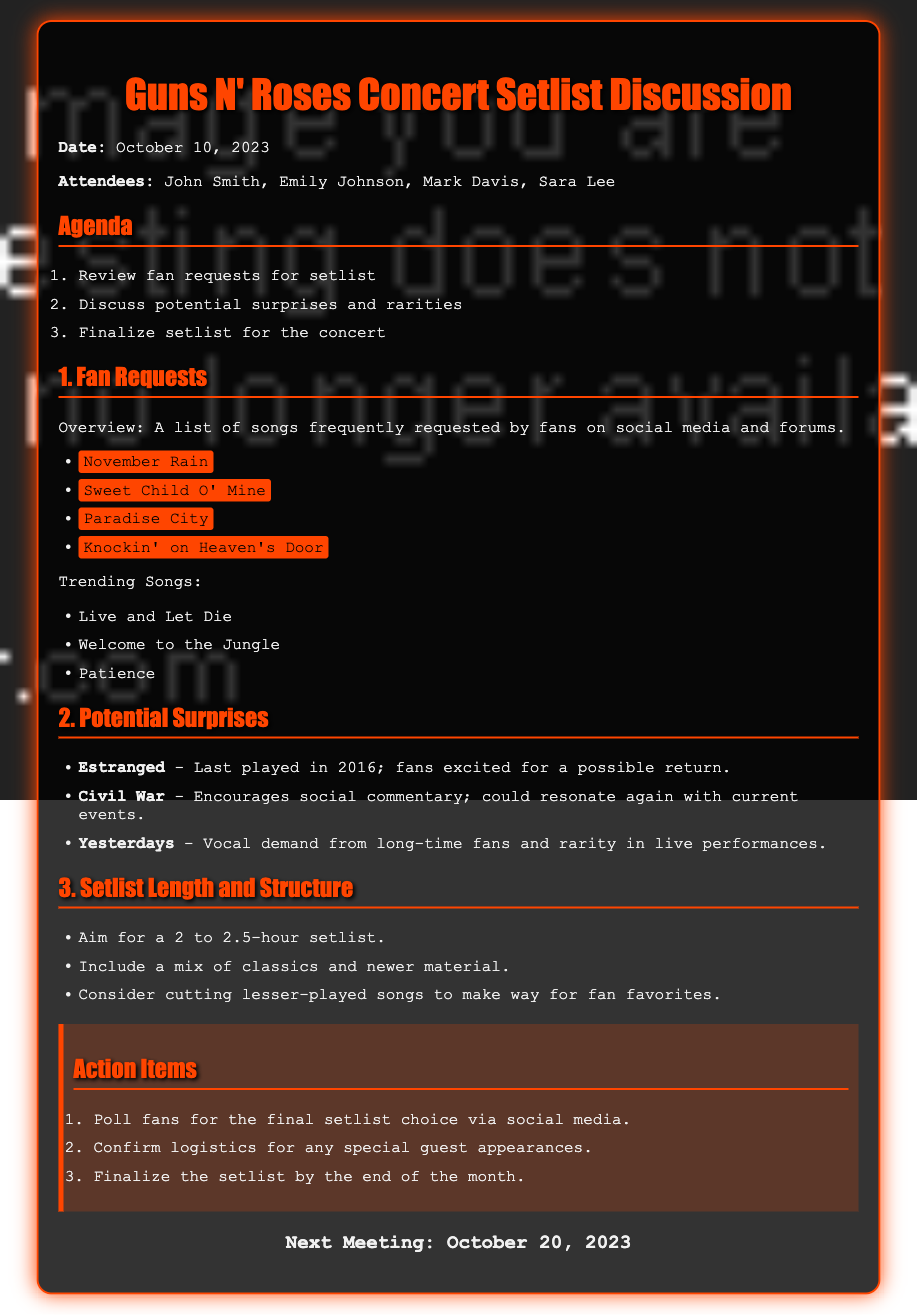what is the date of the meeting? The date of the meeting is explicitly mentioned in the document as October 10, 2023.
Answer: October 10, 2023 who are the attendees of the meeting? The attendees are listed in the document under the "Attendees" section as John Smith, Emily Johnson, Mark Davis, and Sara Lee.
Answer: John Smith, Emily Johnson, Mark Davis, Sara Lee what is one of the trending songs mentioned? The document lists trending songs, one of which is "Live and Let Die".
Answer: Live and Let Die when is the next meeting scheduled? The next meeting date is provided at the end of the document, which is October 20, 2023.
Answer: October 20, 2023 which song last played in 2016 is a potential surprise? The document mentions "Estranged" as a song last played in 2016 that fans are excited about.
Answer: Estranged how long is the aimed setlist duration? The document specifies that the aim is for a 2 to 2.5-hour setlist duration.
Answer: 2 to 2.5 hours what is one action item to engage fans? The action items include polling fans for the final setlist choice via social media.
Answer: Poll fans which song is expected to resonate with current events? "Civil War" is highlighted in the document as it encourages social commentary and could resonate with current events.
Answer: Civil War what type of songs should be included in the setlist? The setlist should include a mix of classics and newer material according to the document.
Answer: Classics and newer material 